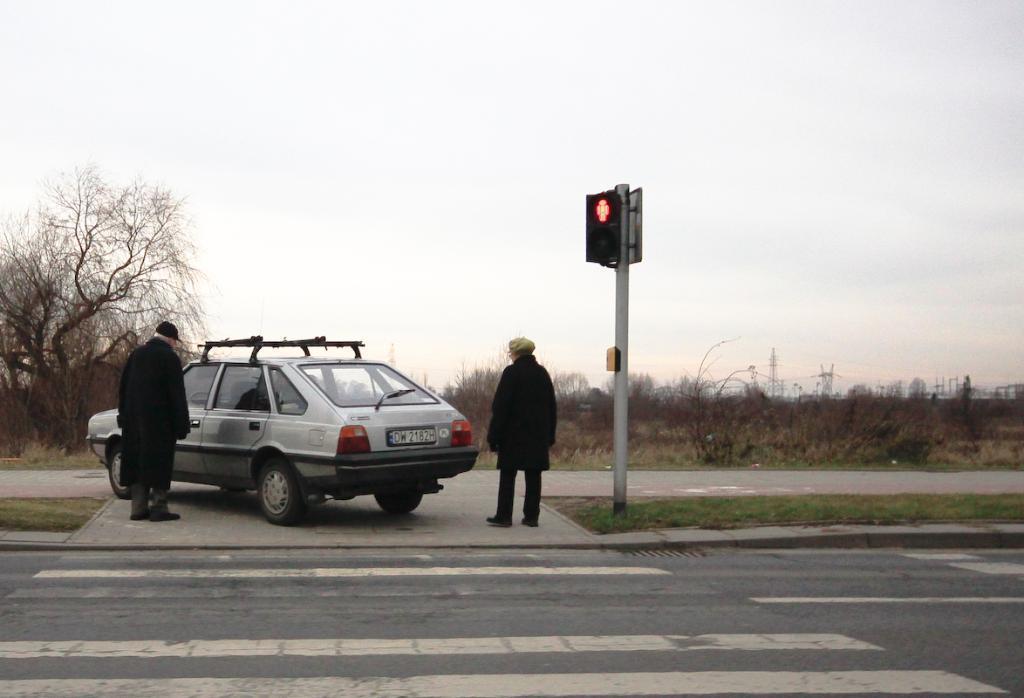Please provide a concise description of this image. In this image there are two persons standing, vehicle , signal lights attached to the pole, and in the background there are plants, trees , cell towers,sky. 